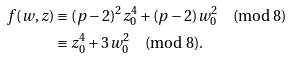<formula> <loc_0><loc_0><loc_500><loc_500>f ( w , z ) & \equiv ( p - 2 ) ^ { 2 } z _ { 0 } ^ { 4 } + ( p - 2 ) w _ { 0 } ^ { 2 } \quad \text {(mod $8$)} \\ & \equiv z _ { 0 } ^ { 4 } + 3 w _ { 0 } ^ { 2 } \quad \text {(mod $8$)} .</formula> 